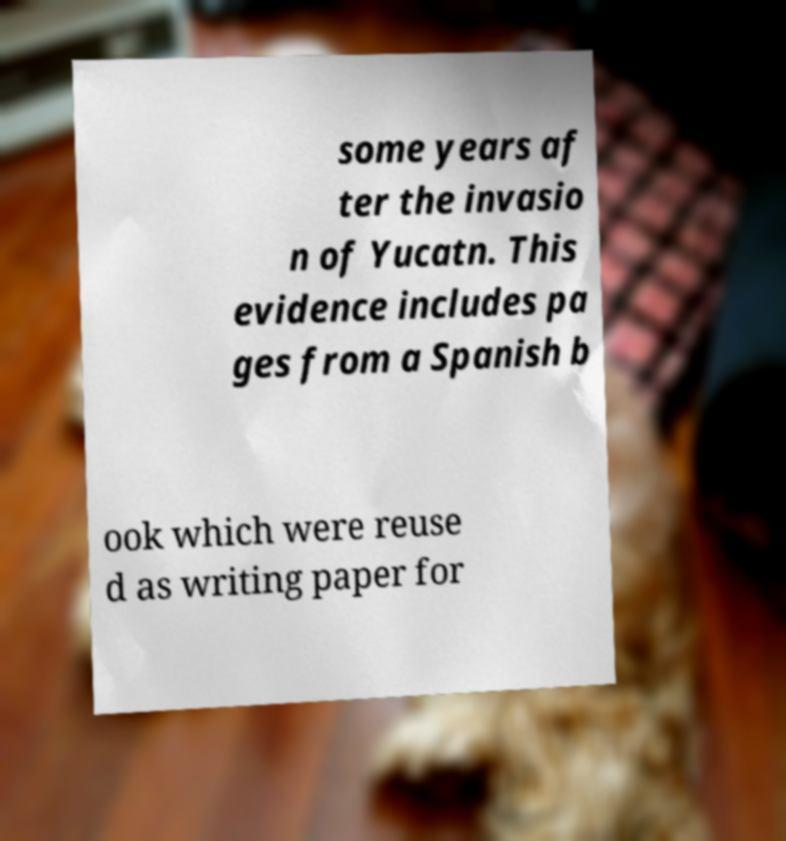Could you assist in decoding the text presented in this image and type it out clearly? some years af ter the invasio n of Yucatn. This evidence includes pa ges from a Spanish b ook which were reuse d as writing paper for 